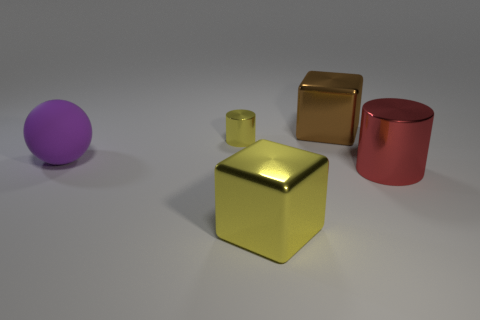Add 3 big cyan matte spheres. How many objects exist? 8 Subtract all yellow cylinders. How many cylinders are left? 1 Subtract 2 cylinders. How many cylinders are left? 0 Subtract all gray cylinders. Subtract all green spheres. How many cylinders are left? 2 Subtract 0 blue balls. How many objects are left? 5 Subtract all spheres. How many objects are left? 4 Subtract all big gray shiny objects. Subtract all brown metal blocks. How many objects are left? 4 Add 1 big red metal cylinders. How many big red metal cylinders are left? 2 Add 2 tiny red cubes. How many tiny red cubes exist? 2 